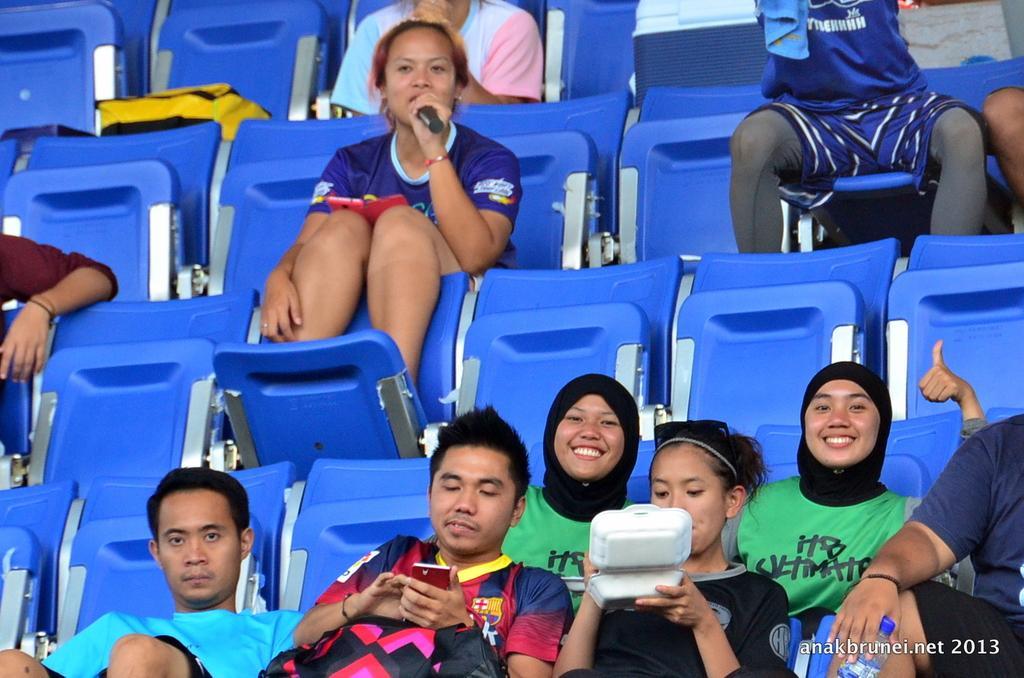Describe this image in one or two sentences. In this picture I can see a woman seated on the chairs and I can see a woman holding a microphone and speaking and another woman holding a box and eating something and a man holding a mobile in his hand and I can see a bag on the chair and I can see text at the bottom right corner of the picture. 